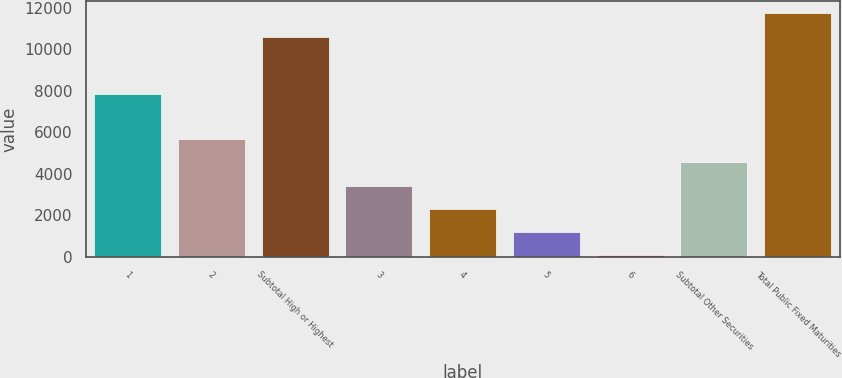Convert chart. <chart><loc_0><loc_0><loc_500><loc_500><bar_chart><fcel>1<fcel>2<fcel>Subtotal High or Highest<fcel>3<fcel>4<fcel>5<fcel>6<fcel>Subtotal Other Securities<fcel>Total Public Fixed Maturities<nl><fcel>7836<fcel>5661<fcel>10604<fcel>3423.4<fcel>2304.6<fcel>1185.8<fcel>67<fcel>4542.2<fcel>11722.8<nl></chart> 